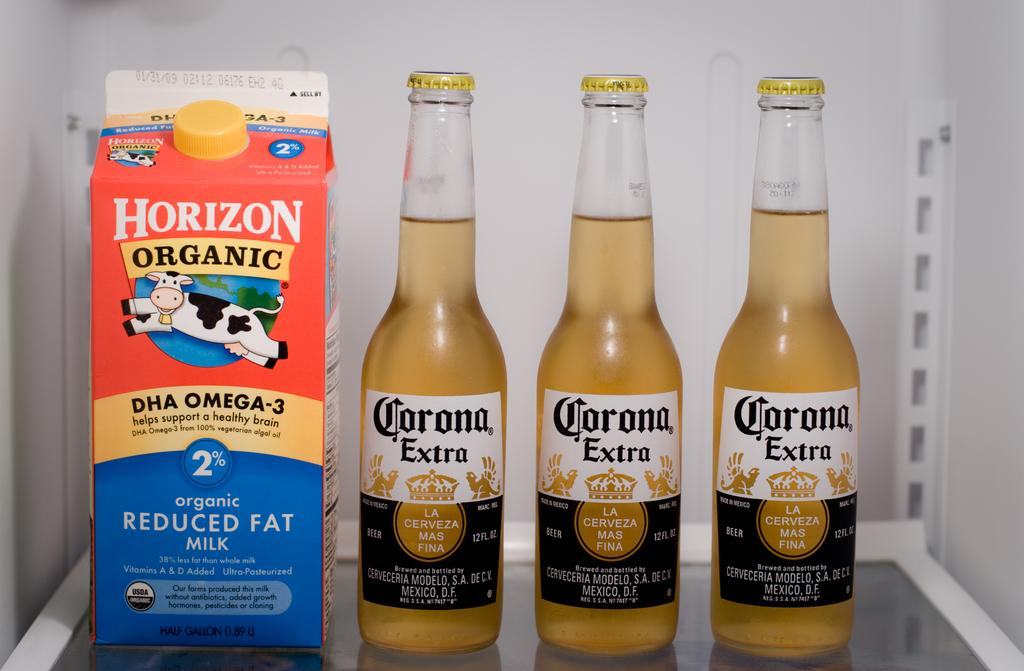How many bottles can be seen in the image? There are three bottles in the image. What is located on the table in the image? There is an object on the table in the image. What can be found on the bottles in the image? The bottles have labels. What else in the image has labels? The wall in the image has labels. What type of headgear is the person wearing in the image? There is no person present in the image, so it is not possible to determine if they are wearing any headgear. 